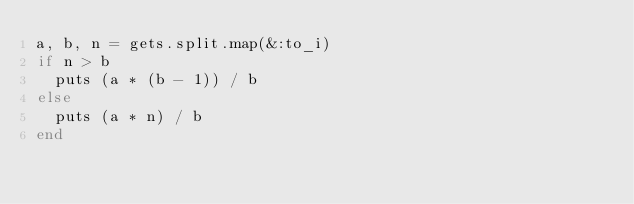<code> <loc_0><loc_0><loc_500><loc_500><_Ruby_>a, b, n = gets.split.map(&:to_i)
if n > b
  puts (a * (b - 1)) / b
else
  puts (a * n) / b
end</code> 